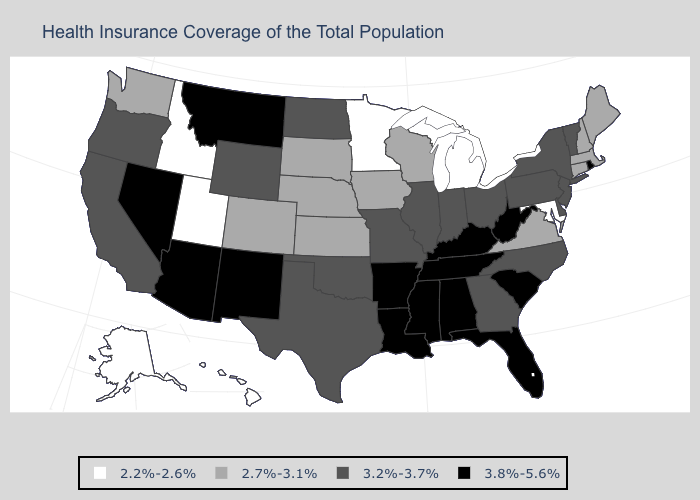Name the states that have a value in the range 2.7%-3.1%?
Write a very short answer. Colorado, Connecticut, Iowa, Kansas, Maine, Massachusetts, Nebraska, New Hampshire, South Dakota, Virginia, Washington, Wisconsin. What is the value of North Carolina?
Short answer required. 3.2%-3.7%. Among the states that border Nebraska , does Colorado have the highest value?
Give a very brief answer. No. Does New Mexico have the highest value in the USA?
Keep it brief. Yes. Among the states that border Minnesota , does Iowa have the highest value?
Quick response, please. No. Name the states that have a value in the range 2.2%-2.6%?
Concise answer only. Alaska, Hawaii, Idaho, Maryland, Michigan, Minnesota, Utah. Name the states that have a value in the range 2.7%-3.1%?
Answer briefly. Colorado, Connecticut, Iowa, Kansas, Maine, Massachusetts, Nebraska, New Hampshire, South Dakota, Virginia, Washington, Wisconsin. Does Maryland have the lowest value in the South?
Answer briefly. Yes. Name the states that have a value in the range 3.8%-5.6%?
Concise answer only. Alabama, Arizona, Arkansas, Florida, Kentucky, Louisiana, Mississippi, Montana, Nevada, New Mexico, Rhode Island, South Carolina, Tennessee, West Virginia. Does the map have missing data?
Write a very short answer. No. What is the value of California?
Write a very short answer. 3.2%-3.7%. Name the states that have a value in the range 3.2%-3.7%?
Concise answer only. California, Delaware, Georgia, Illinois, Indiana, Missouri, New Jersey, New York, North Carolina, North Dakota, Ohio, Oklahoma, Oregon, Pennsylvania, Texas, Vermont, Wyoming. Which states have the lowest value in the MidWest?
Concise answer only. Michigan, Minnesota. What is the value of Kentucky?
Concise answer only. 3.8%-5.6%. What is the value of Colorado?
Write a very short answer. 2.7%-3.1%. 